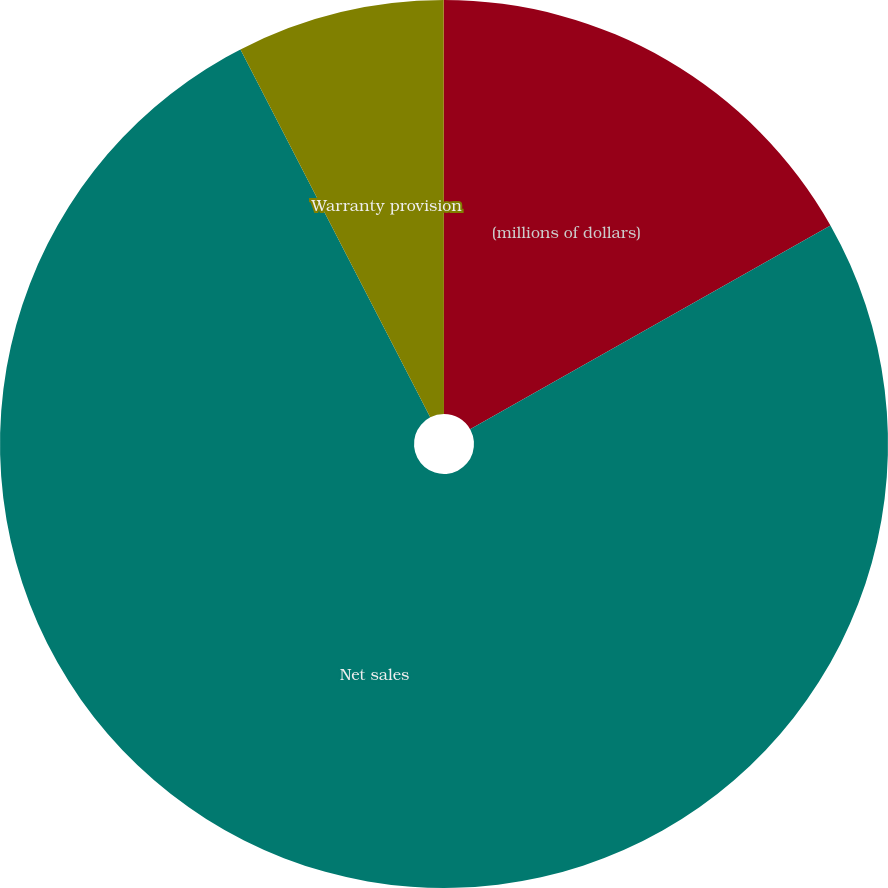Convert chart to OTSL. <chart><loc_0><loc_0><loc_500><loc_500><pie_chart><fcel>(millions of dollars)<fcel>Net sales<fcel>Warranty provision<fcel>Warranty provision as a<nl><fcel>16.81%<fcel>75.62%<fcel>7.57%<fcel>0.01%<nl></chart> 